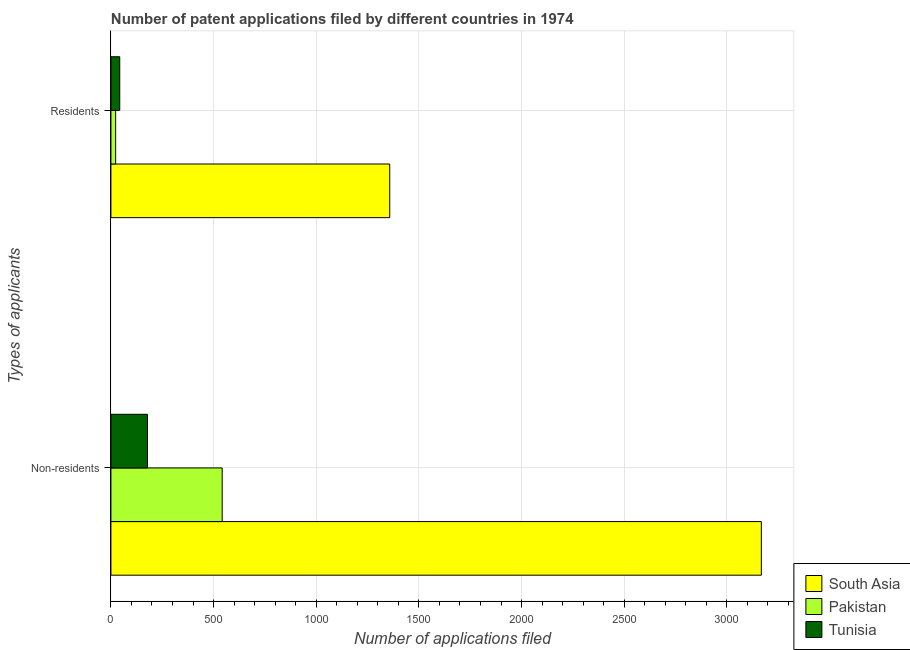How many different coloured bars are there?
Offer a very short reply. 3. Are the number of bars per tick equal to the number of legend labels?
Provide a short and direct response. Yes. How many bars are there on the 1st tick from the top?
Your answer should be compact. 3. What is the label of the 1st group of bars from the top?
Make the answer very short. Residents. What is the number of patent applications by non residents in Pakistan?
Offer a very short reply. 542. Across all countries, what is the maximum number of patent applications by residents?
Give a very brief answer. 1358. Across all countries, what is the minimum number of patent applications by residents?
Make the answer very short. 23. In which country was the number of patent applications by non residents minimum?
Your response must be concise. Tunisia. What is the total number of patent applications by non residents in the graph?
Offer a terse response. 3888. What is the difference between the number of patent applications by residents in Tunisia and that in Pakistan?
Give a very brief answer. 20. What is the difference between the number of patent applications by residents in Tunisia and the number of patent applications by non residents in Pakistan?
Your answer should be compact. -499. What is the average number of patent applications by non residents per country?
Provide a succinct answer. 1296. What is the difference between the number of patent applications by residents and number of patent applications by non residents in South Asia?
Your answer should be compact. -1810. What is the ratio of the number of patent applications by residents in Tunisia to that in Pakistan?
Make the answer very short. 1.87. Is the number of patent applications by residents in Tunisia less than that in South Asia?
Make the answer very short. Yes. In how many countries, is the number of patent applications by non residents greater than the average number of patent applications by non residents taken over all countries?
Offer a very short reply. 1. What does the 3rd bar from the top in Residents represents?
Offer a terse response. South Asia. What does the 3rd bar from the bottom in Residents represents?
Make the answer very short. Tunisia. How many bars are there?
Ensure brevity in your answer.  6. Are all the bars in the graph horizontal?
Provide a succinct answer. Yes. What is the difference between two consecutive major ticks on the X-axis?
Keep it short and to the point. 500. Are the values on the major ticks of X-axis written in scientific E-notation?
Keep it short and to the point. No. Does the graph contain any zero values?
Keep it short and to the point. No. Does the graph contain grids?
Your answer should be compact. Yes. What is the title of the graph?
Offer a very short reply. Number of patent applications filed by different countries in 1974. Does "Nepal" appear as one of the legend labels in the graph?
Your answer should be compact. No. What is the label or title of the X-axis?
Your answer should be very brief. Number of applications filed. What is the label or title of the Y-axis?
Offer a terse response. Types of applicants. What is the Number of applications filed of South Asia in Non-residents?
Provide a succinct answer. 3168. What is the Number of applications filed of Pakistan in Non-residents?
Offer a terse response. 542. What is the Number of applications filed in Tunisia in Non-residents?
Offer a very short reply. 178. What is the Number of applications filed of South Asia in Residents?
Provide a short and direct response. 1358. What is the Number of applications filed in Pakistan in Residents?
Offer a very short reply. 23. What is the Number of applications filed in Tunisia in Residents?
Offer a terse response. 43. Across all Types of applicants, what is the maximum Number of applications filed of South Asia?
Ensure brevity in your answer.  3168. Across all Types of applicants, what is the maximum Number of applications filed in Pakistan?
Your answer should be very brief. 542. Across all Types of applicants, what is the maximum Number of applications filed of Tunisia?
Make the answer very short. 178. Across all Types of applicants, what is the minimum Number of applications filed of South Asia?
Offer a very short reply. 1358. What is the total Number of applications filed of South Asia in the graph?
Provide a short and direct response. 4526. What is the total Number of applications filed of Pakistan in the graph?
Offer a very short reply. 565. What is the total Number of applications filed of Tunisia in the graph?
Make the answer very short. 221. What is the difference between the Number of applications filed in South Asia in Non-residents and that in Residents?
Offer a very short reply. 1810. What is the difference between the Number of applications filed of Pakistan in Non-residents and that in Residents?
Your answer should be compact. 519. What is the difference between the Number of applications filed in Tunisia in Non-residents and that in Residents?
Keep it short and to the point. 135. What is the difference between the Number of applications filed in South Asia in Non-residents and the Number of applications filed in Pakistan in Residents?
Your answer should be compact. 3145. What is the difference between the Number of applications filed of South Asia in Non-residents and the Number of applications filed of Tunisia in Residents?
Ensure brevity in your answer.  3125. What is the difference between the Number of applications filed of Pakistan in Non-residents and the Number of applications filed of Tunisia in Residents?
Offer a terse response. 499. What is the average Number of applications filed in South Asia per Types of applicants?
Your response must be concise. 2263. What is the average Number of applications filed of Pakistan per Types of applicants?
Make the answer very short. 282.5. What is the average Number of applications filed of Tunisia per Types of applicants?
Offer a very short reply. 110.5. What is the difference between the Number of applications filed in South Asia and Number of applications filed in Pakistan in Non-residents?
Keep it short and to the point. 2626. What is the difference between the Number of applications filed of South Asia and Number of applications filed of Tunisia in Non-residents?
Your response must be concise. 2990. What is the difference between the Number of applications filed in Pakistan and Number of applications filed in Tunisia in Non-residents?
Provide a succinct answer. 364. What is the difference between the Number of applications filed in South Asia and Number of applications filed in Pakistan in Residents?
Offer a terse response. 1335. What is the difference between the Number of applications filed in South Asia and Number of applications filed in Tunisia in Residents?
Your answer should be compact. 1315. What is the difference between the Number of applications filed of Pakistan and Number of applications filed of Tunisia in Residents?
Make the answer very short. -20. What is the ratio of the Number of applications filed of South Asia in Non-residents to that in Residents?
Ensure brevity in your answer.  2.33. What is the ratio of the Number of applications filed of Pakistan in Non-residents to that in Residents?
Offer a terse response. 23.57. What is the ratio of the Number of applications filed of Tunisia in Non-residents to that in Residents?
Your answer should be compact. 4.14. What is the difference between the highest and the second highest Number of applications filed of South Asia?
Make the answer very short. 1810. What is the difference between the highest and the second highest Number of applications filed of Pakistan?
Ensure brevity in your answer.  519. What is the difference between the highest and the second highest Number of applications filed of Tunisia?
Provide a short and direct response. 135. What is the difference between the highest and the lowest Number of applications filed of South Asia?
Offer a terse response. 1810. What is the difference between the highest and the lowest Number of applications filed of Pakistan?
Make the answer very short. 519. What is the difference between the highest and the lowest Number of applications filed in Tunisia?
Your answer should be very brief. 135. 